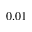Convert formula to latex. <formula><loc_0><loc_0><loc_500><loc_500>0 . 0 1</formula> 